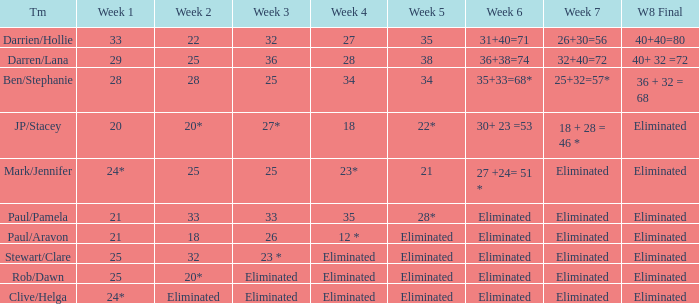Name the team for week 1 of 28 Ben/Stephanie. Help me parse the entirety of this table. {'header': ['Tm', 'Week 1', 'Week 2', 'Week 3', 'Week 4', 'Week 5', 'Week 6', 'Week 7', 'W8 Final'], 'rows': [['Darrien/Hollie', '33', '22', '32', '27', '35', '31+40=71', '26+30=56', '40+40=80'], ['Darren/Lana', '29', '25', '36', '28', '38', '36+38=74', '32+40=72', '40+ 32 =72'], ['Ben/Stephanie', '28', '28', '25', '34', '34', '35+33=68*', '25+32=57*', '36 + 32 = 68'], ['JP/Stacey', '20', '20*', '27*', '18', '22*', '30+ 23 =53', '18 + 28 = 46 *', 'Eliminated'], ['Mark/Jennifer', '24*', '25', '25', '23*', '21', '27 +24= 51 *', 'Eliminated', 'Eliminated'], ['Paul/Pamela', '21', '33', '33', '35', '28*', 'Eliminated', 'Eliminated', 'Eliminated'], ['Paul/Aravon', '21', '18', '26', '12 *', 'Eliminated', 'Eliminated', 'Eliminated', 'Eliminated'], ['Stewart/Clare', '25', '32', '23 *', 'Eliminated', 'Eliminated', 'Eliminated', 'Eliminated', 'Eliminated'], ['Rob/Dawn', '25', '20*', 'Eliminated', 'Eliminated', 'Eliminated', 'Eliminated', 'Eliminated', 'Eliminated'], ['Clive/Helga', '24*', 'Eliminated', 'Eliminated', 'Eliminated', 'Eliminated', 'Eliminated', 'Eliminated', 'Eliminated']]} 